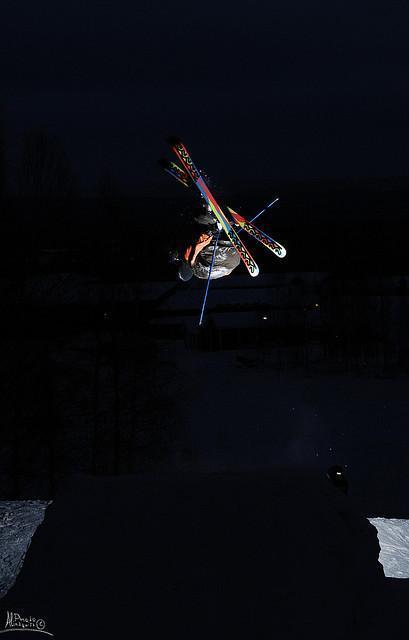How many black umbrellas are there?
Give a very brief answer. 0. 